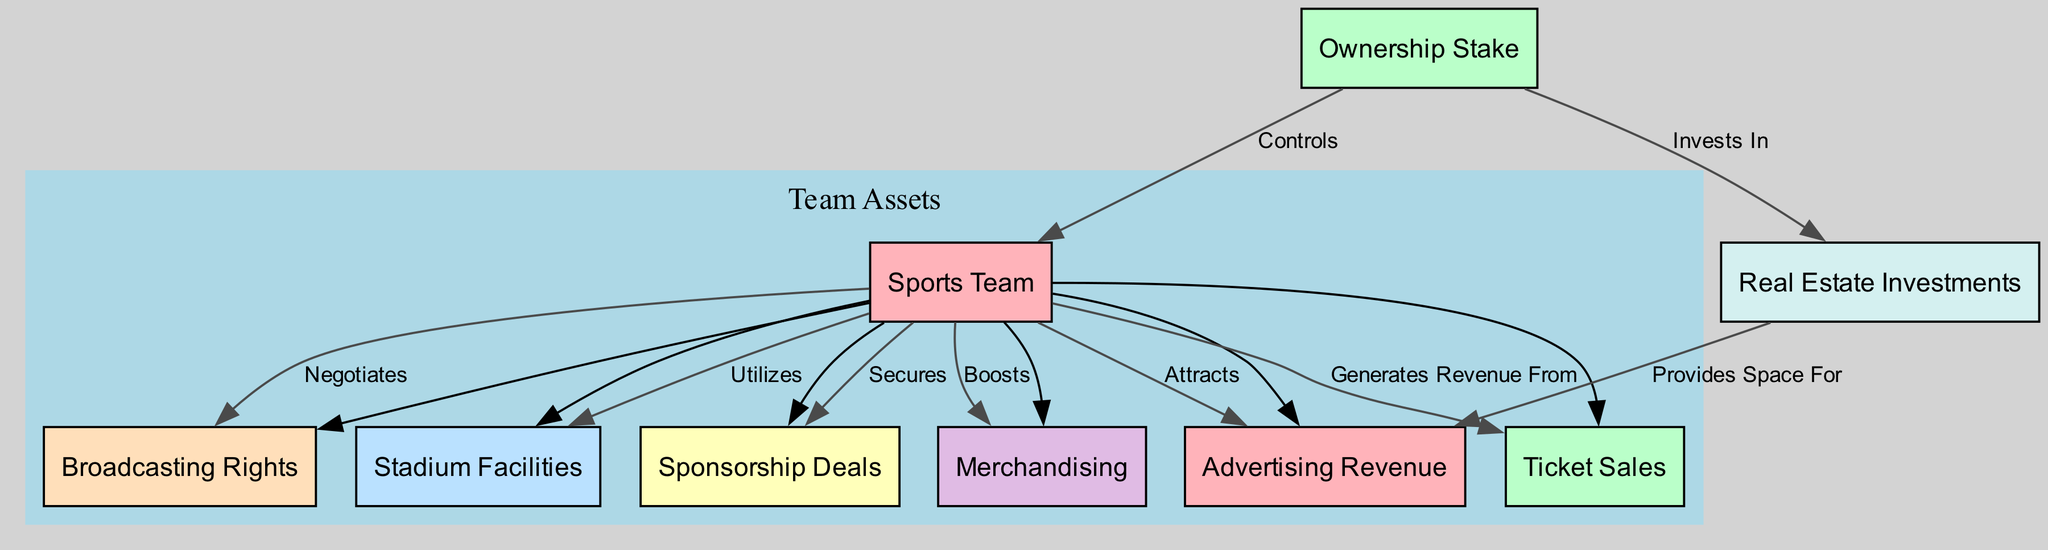What is the central node of the diagram? The central node, often representing the main subject of the diagram, is labeled "Sports Team." This can be identified as it acts as a convergence point for other nodes connected to it, representing various assets and revenue streams.
Answer: Sports Team How many nodes are present in the diagram? To find out the total number of nodes, we count all distinct node elements in the data, which includes "Sports Team," "Ownership Stake," "Stadium Facilities," "Sponsorship Deals," "Broadcasting Rights," "Merchandising," "Real Estate Investments," "Advertising Revenue," and "Ticket Sales." There are 9 distinct node elements.
Answer: 9 Which node is directly connected to the "Ownership Stake" node? The "Ownership Stake" node is directly connected to the "Sports Team" node, indicated by the edge labeled "Controls," establishing a direct relationship.
Answer: Sports Team What type of relationship does the "Sports Team" have with the "Stadium Facilities"? The relationship between "Sports Team" and "Stadium Facilities" is indicated by the edge labeled "Utilizes," meaning the team uses the stadium facilities for its operations.
Answer: Utilizes How does the "Real Estate Investments" node contribute to the "Advertising Revenue"? The node "Real Estate Investments" connects to "Advertising Revenue" through the edge labeled "Provides Space For," indicating that the real estate holdings offer locations for advertising, thus contributing to revenue.
Answer: Provides Space For What is the total number of edges in the diagram? The total number of edges is counted by listing each directed connection between nodes which are indicated in the diagram. A thorough count shows there are 8 edges connecting the nodes.
Answer: 8 Which revenue-generating venture does the "Sponsorship Deals" node belong to? The "Sponsorship Deals" node is directly associated with the "Sports Team" node, establishing that it is a revenue-generating venture secured by the team.
Answer: Sports Team Which node is categorized under "Team Assets"? The "Team Assets" category includes the nodes: "Stadium Facilities," "Sponsorship Deals," "Broadcasting Rights," "Merchandising," "Advertising Revenue," and "Ticket Sales." These nodes are all connected to the "Sports Team" node, thus falling under team assets.
Answer: Stadium Facilities, Sponsorship Deals, Broadcasting Rights, Merchandising, Advertising Revenue, Ticket Sales What does the "Merchandising" node indicate in relation to the team's revenue? The "Merchandising" node illustrates that the team boosts its revenue through sales of merchandise connected to its brand, indicating a form of revenue generation.
Answer: Boosts 